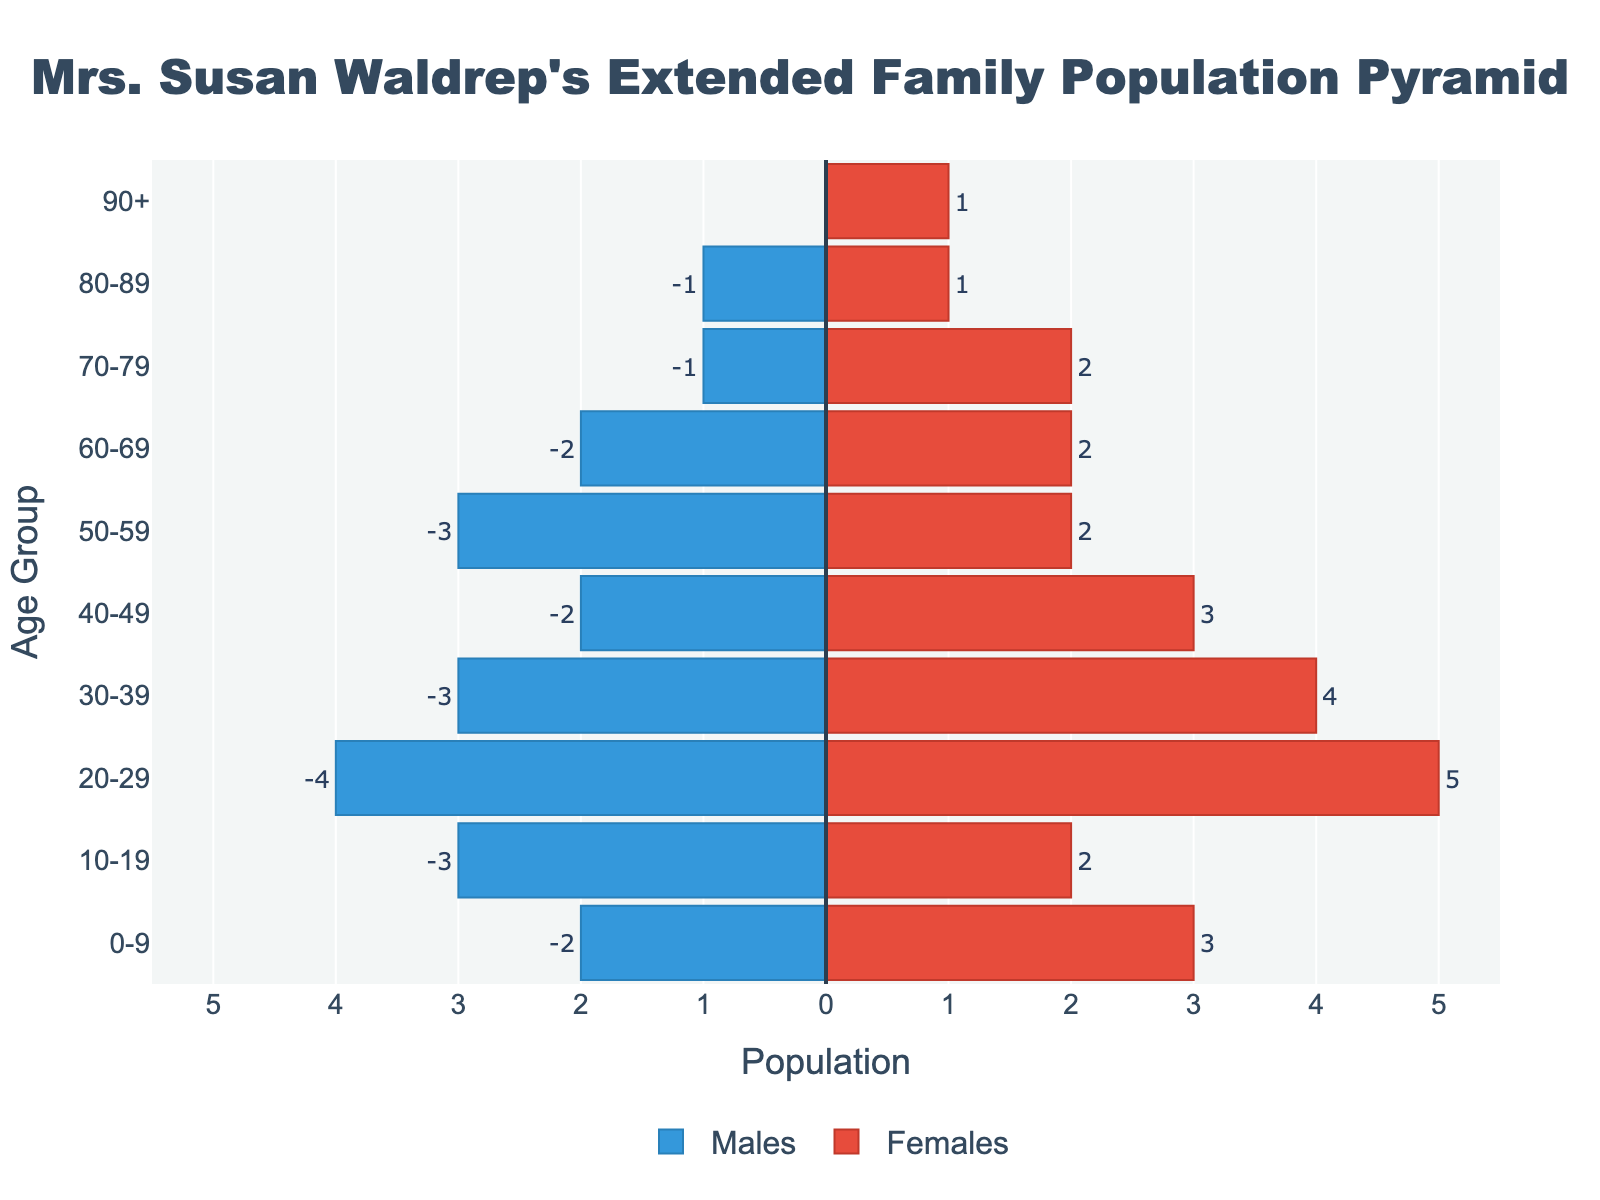How many females are in the 20-29 age group? Look at the bar representing the females in the 20-29 age group. The value is clearly marked outside the bar.
Answer: 5 How many more males are there than females in the 10-19 age group? Compare the number of males and females in the 10-19 age group. There are 3 males and 2 females, so the difference is 3 - 2.
Answer: 1 Which age group has the highest number of people overall? Sum the number of males and females for each age group and compare them. The 20-29 age group has 4 males and 5 females, totaling 9, which is the highest.
Answer: 20-29 Is there any age group where the number of males equals the number of females? Check each age group to see if the males and females values are equal. The 60-69 and 80-89 age groups both have 2 males and 2 females and 1 male and 1 female respectively.
Answer: Yes, 60-69 and 80-89 What is the total population in the pyramid across all age groups? Sum up all males and females across each age group. Totals are: 2+3, 3+2, 4+5, 3+4, 2+3, 3+2, 2+2, 1+2, 1+1, 0+1 = 43.
Answer: 43 Which gender has more people in the age group 70-79? Compare the number of males and females in the 70-79 age group. There is 1 male and 2 females. Females are more.
Answer: Females How many more females are there compared to males in the 30-39 age group? Look at the 30-39 age group: 4 females and 3 males. The difference is 4 - 3.
Answer: 1 What is the age range with the smallest population? Compare the total population for each age group. The 90+ age group has the smallest population with only 1 person.
Answer: 90+ How many people are aged 50-59? Sum the number of males and females in the 50-59 age group, which are 3 and 2 respectively. 3 + 2 = 5.
Answer: 5 Which age group has a balanced gender distribution (same number of males and females)? Check each age group to find one with equal numbers of males and females. The 60-69 group has 2 males and 2 females.
Answer: 60-69 